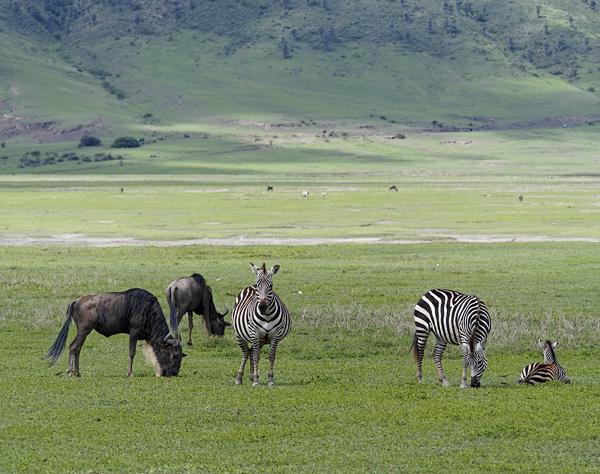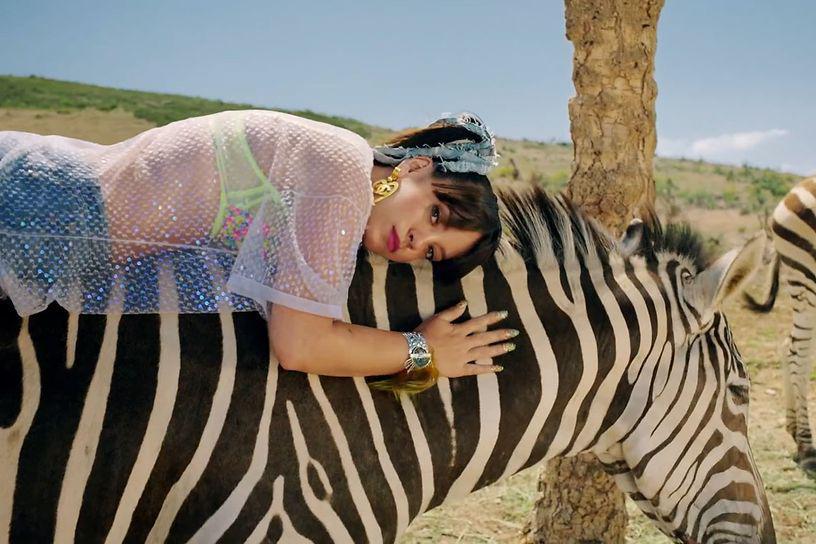The first image is the image on the left, the second image is the image on the right. Given the left and right images, does the statement "The left image includes a zebra colt standing and facing leftward, and the right image contains a rightward-facing zebra standing closest in the foreground." hold true? Answer yes or no. No. The first image is the image on the left, the second image is the image on the right. Analyze the images presented: Is the assertion "In the left image there are two or more zebras moving forward in the same direction." valid? Answer yes or no. No. 